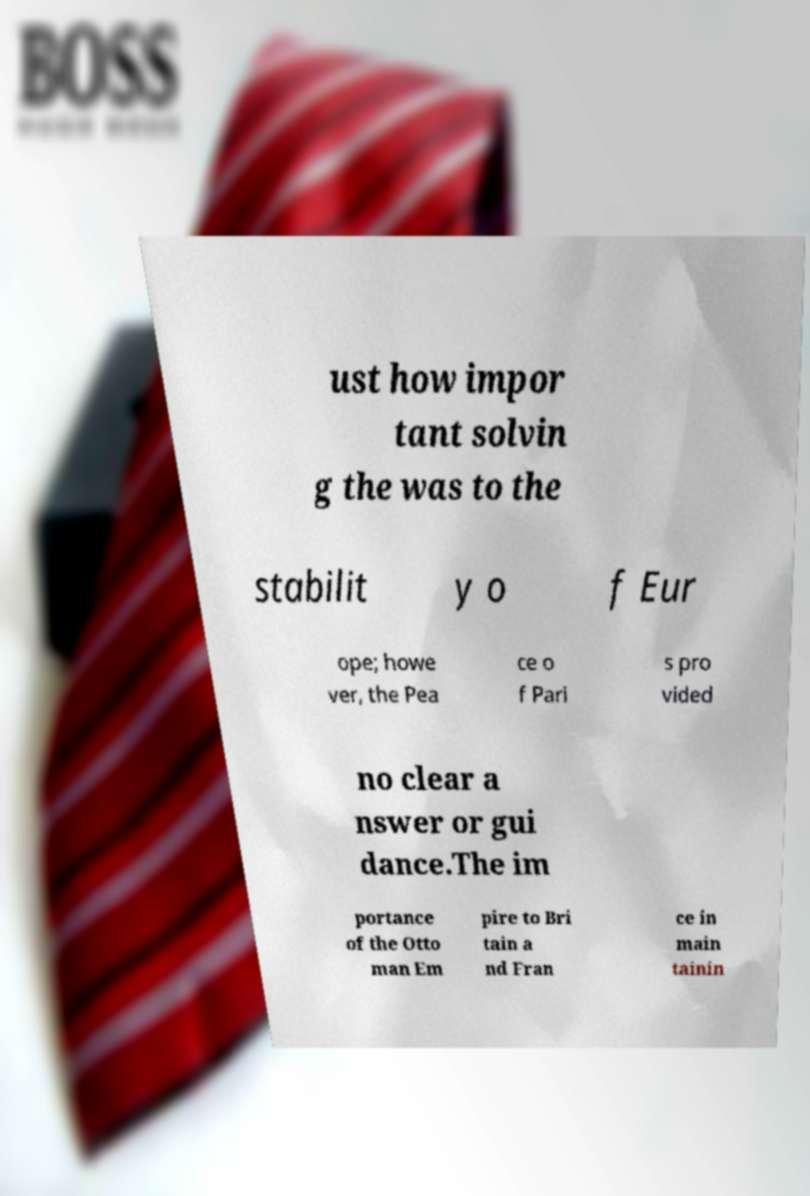There's text embedded in this image that I need extracted. Can you transcribe it verbatim? ust how impor tant solvin g the was to the stabilit y o f Eur ope; howe ver, the Pea ce o f Pari s pro vided no clear a nswer or gui dance.The im portance of the Otto man Em pire to Bri tain a nd Fran ce in main tainin 